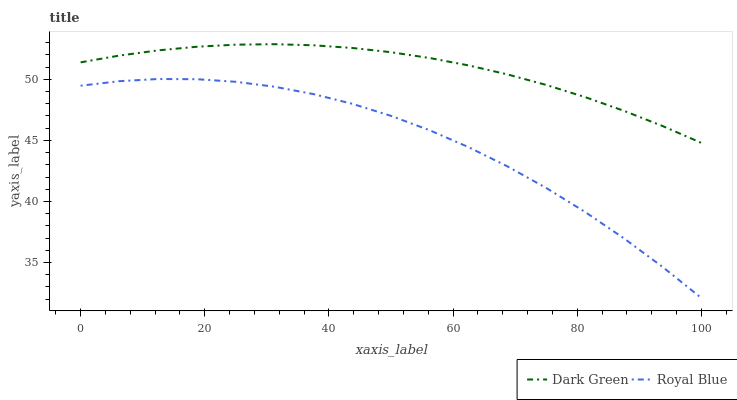Does Royal Blue have the minimum area under the curve?
Answer yes or no. Yes. Does Dark Green have the maximum area under the curve?
Answer yes or no. Yes. Does Dark Green have the minimum area under the curve?
Answer yes or no. No. Is Dark Green the smoothest?
Answer yes or no. Yes. Is Royal Blue the roughest?
Answer yes or no. Yes. Is Dark Green the roughest?
Answer yes or no. No. Does Dark Green have the lowest value?
Answer yes or no. No. Does Dark Green have the highest value?
Answer yes or no. Yes. Is Royal Blue less than Dark Green?
Answer yes or no. Yes. Is Dark Green greater than Royal Blue?
Answer yes or no. Yes. Does Royal Blue intersect Dark Green?
Answer yes or no. No. 